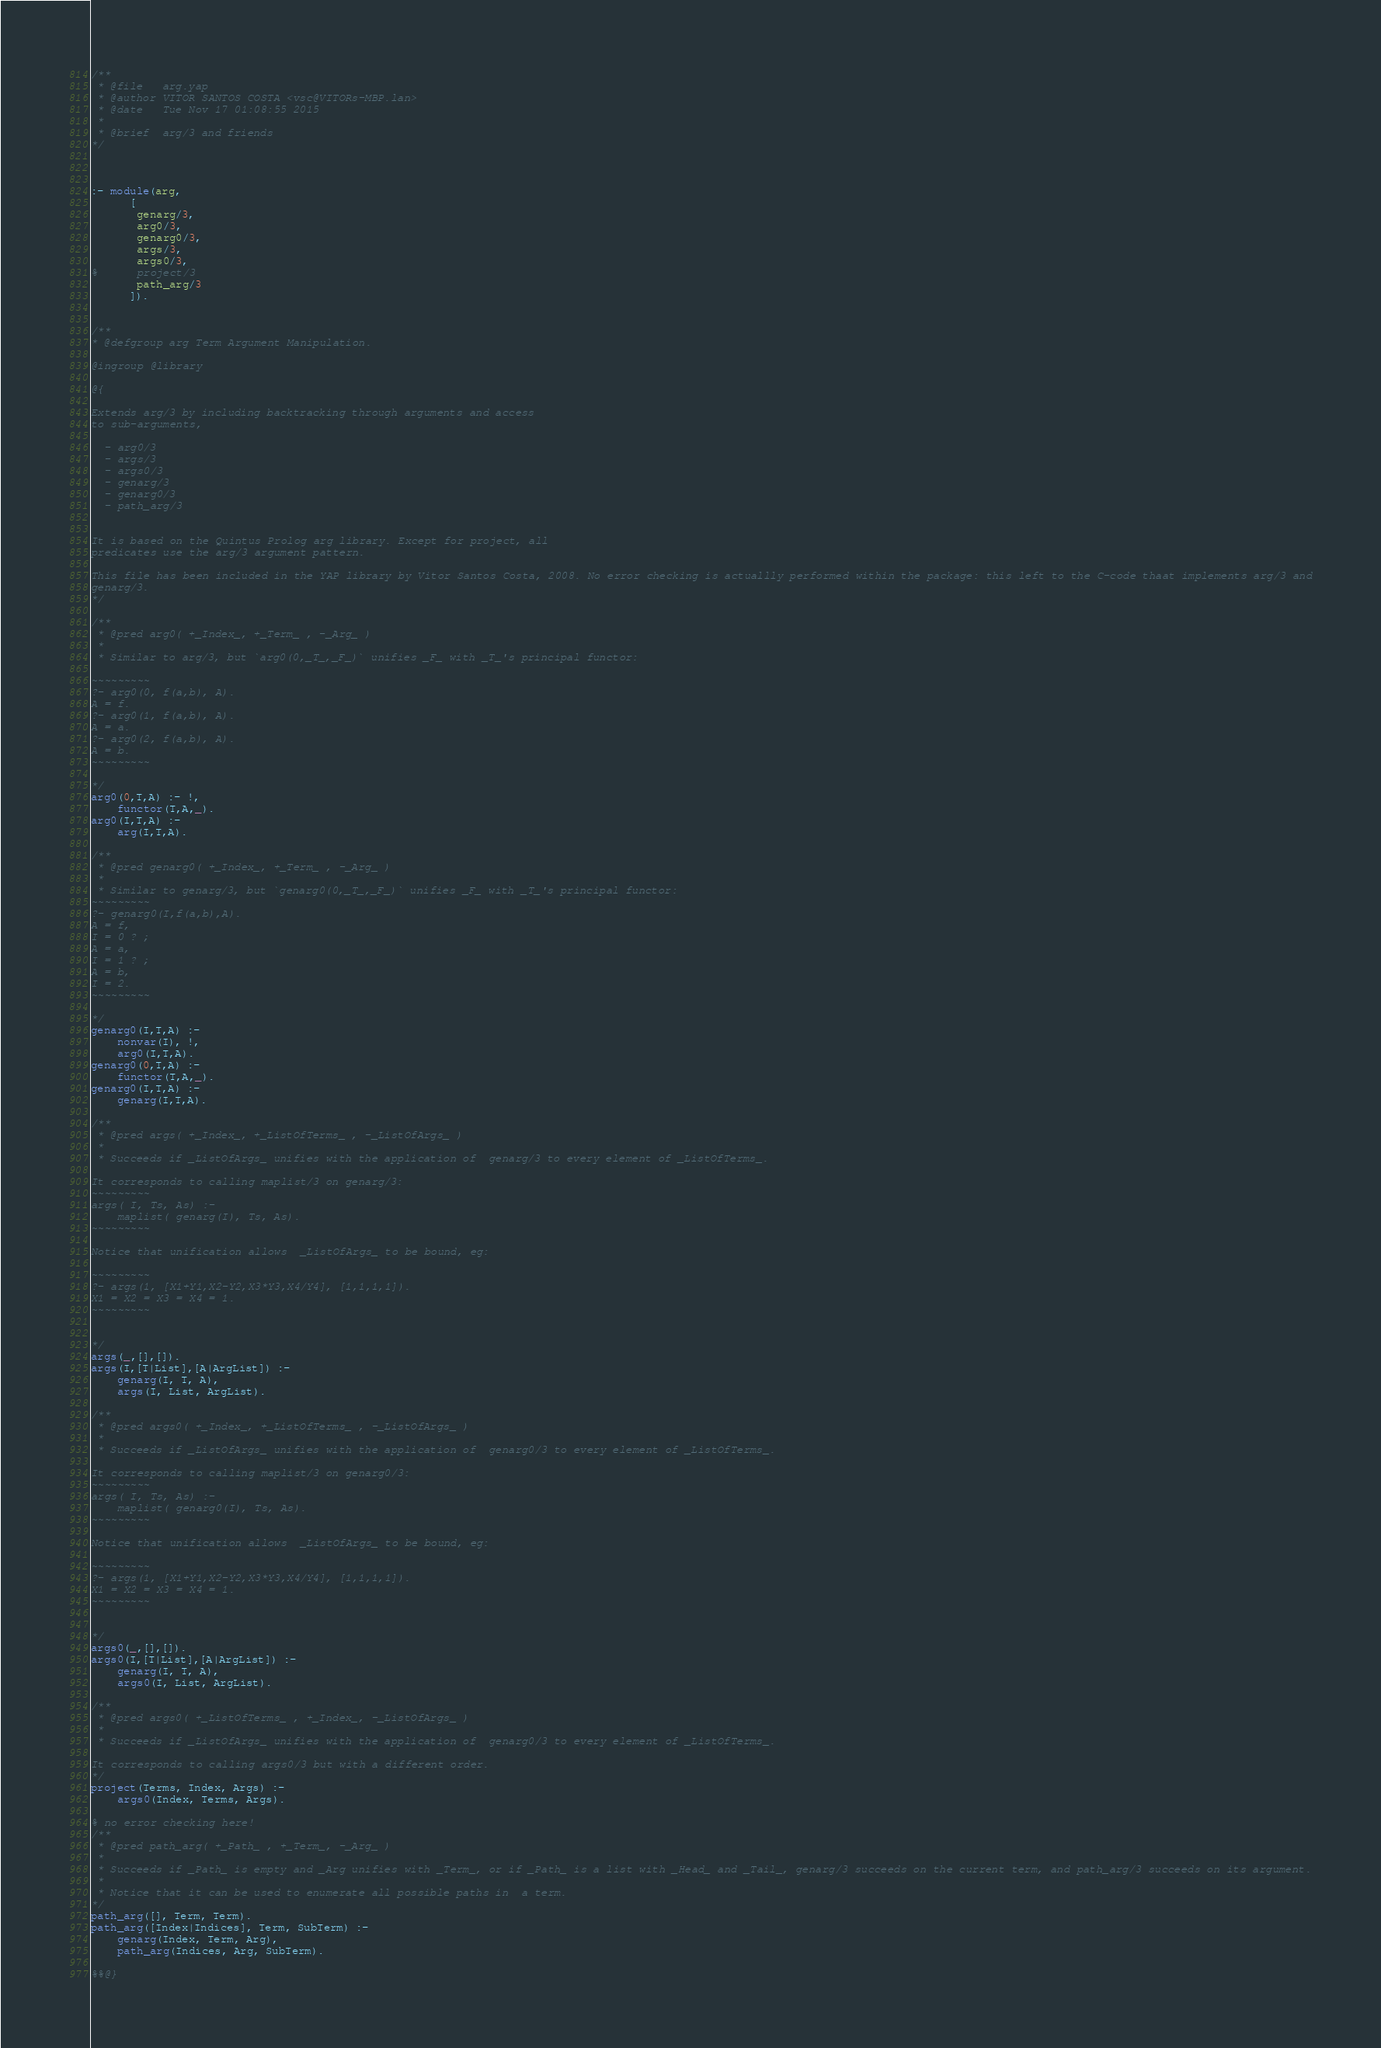<code> <loc_0><loc_0><loc_500><loc_500><_Prolog_>/**
 * @file   arg.yap
 * @author VITOR SANTOS COSTA <vsc@VITORs-MBP.lan>
 * @date   Tue Nov 17 01:08:55 2015
 * 
 * @brief  arg/3 and friends
*/



:- module(arg,
	  [
	   genarg/3,
	   arg0/3,
	   genarg0/3,
	   args/3,
	   args0/3,
%	   project/3
	   path_arg/3
	  ]).


/**
* @defgroup arg Term Argument Manipulation.

@ingroup @library

@{

Extends arg/3 by including backtracking through arguments and access
to sub-arguments,

  - arg0/3
  - args/3
  - args0/3
  - genarg/3
  - genarg0/3
  - path_arg/3


It is based on the Quintus Prolog arg library. Except for project, all
predicates use the arg/3 argument pattern.

This file has been included in the YAP library by Vitor Santos Costa, 2008. No error checking is actuallly performed within the package: this left to the C-code thaat implements arg/3 and
genarg/3.
*/

/** 
 * @pred arg0( +_Index_, +_Term_ , -_Arg_ )
 * 
 * Similar to arg/3, but `arg0(0,_T_,_F_)` unifies _F_ with _T_'s principal functor:

~~~~~~~~~
?- arg0(0, f(a,b), A).
A = f.
?- arg0(1, f(a,b), A).
A = a.
?- arg0(2, f(a,b), A).
A = b.
~~~~~~~~~

*/
arg0(0,T,A) :- !,
	functor(T,A,_).
arg0(I,T,A) :-
	arg(I,T,A).

/** 
 * @pred genarg0( +_Index_, +_Term_ , -_Arg_ )
 * 
 * Similar to genarg/3, but `genarg0(0,_T_,_F_)` unifies _F_ with _T_'s principal functor:
~~~~~~~~~
?- genarg0(I,f(a,b),A).
A = f,
I = 0 ? ;
A = a,
I = 1 ? ;
A = b,
I = 2.
~~~~~~~~~

*/
genarg0(I,T,A) :-
	nonvar(I), !,
	arg0(I,T,A).
genarg0(0,T,A) :-
	functor(T,A,_).
genarg0(I,T,A) :-
	genarg(I,T,A).

/** 
 * @pred args( +_Index_, +_ListOfTerms_ , -_ListOfArgs_ )
 * 
 * Succeeds if _ListOfArgs_ unifies with the application of  genarg/3 to every element of _ListOfTerms_.

It corresponds to calling maplist/3 on genarg/3:
~~~~~~~~~
args( I, Ts, As) :-
    maplist( genarg(I), Ts, As).
~~~~~~~~~

Notice that unification allows  _ListOfArgs_ to be bound, eg:

~~~~~~~~~
?- args(1, [X1+Y1,X2-Y2,X3*Y3,X4/Y4], [1,1,1,1]).
X1 = X2 = X3 = X4 = 1.
~~~~~~~~~


*/
args(_,[],[]).
args(I,[T|List],[A|ArgList]) :-
	genarg(I, T, A),
	args(I, List, ArgList).

/** 
 * @pred args0( +_Index_, +_ListOfTerms_ , -_ListOfArgs_ )
 * 
 * Succeeds if _ListOfArgs_ unifies with the application of  genarg0/3 to every element of _ListOfTerms_.

It corresponds to calling maplist/3 on genarg0/3:
~~~~~~~~~
args( I, Ts, As) :-
    maplist( genarg0(I), Ts, As).
~~~~~~~~~

Notice that unification allows  _ListOfArgs_ to be bound, eg:

~~~~~~~~~
?- args(1, [X1+Y1,X2-Y2,X3*Y3,X4/Y4], [1,1,1,1]).
X1 = X2 = X3 = X4 = 1.
~~~~~~~~~


*/
args0(_,[],[]).
args0(I,[T|List],[A|ArgList]) :-
	genarg(I, T, A),
	args0(I, List, ArgList).

/** 
 * @pred args0( +_ListOfTerms_ , +_Index_, -_ListOfArgs_ )
 * 
 * Succeeds if _ListOfArgs_ unifies with the application of  genarg0/3 to every element of _ListOfTerms_.

It corresponds to calling args0/3 but with a different order.
*/
project(Terms, Index, Args) :-
	args0(Index, Terms, Args).

% no error checking here!
/** 
 * @pred path_arg( +_Path_ , +_Term_, -_Arg_ )
 * 
 * Succeeds if _Path_ is empty and _Arg unifies with _Term_, or if _Path_ is a list with _Head_ and _Tail_, genarg/3 succeeds on the current term, and path_arg/3 succeeds on its argument.
 *
 * Notice that it can be used to enumerate all possible paths in  a term.
*/
path_arg([], Term, Term).
path_arg([Index|Indices], Term, SubTerm) :-
	genarg(Index, Term, Arg),
	path_arg(Indices, Arg, SubTerm).

%%@}

</code> 